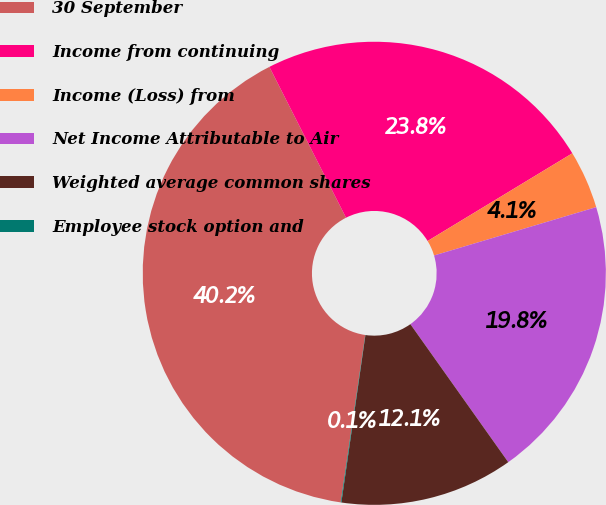Convert chart to OTSL. <chart><loc_0><loc_0><loc_500><loc_500><pie_chart><fcel>30 September<fcel>Income from continuing<fcel>Income (Loss) from<fcel>Net Income Attributable to Air<fcel>Weighted average common shares<fcel>Employee stock option and<nl><fcel>40.19%<fcel>23.81%<fcel>4.06%<fcel>19.79%<fcel>12.09%<fcel>0.05%<nl></chart> 